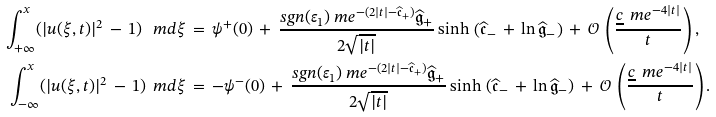Convert formula to latex. <formula><loc_0><loc_0><loc_500><loc_500>\int \nolimits _ { + \infty } ^ { x } ( | u ( \xi , t ) | ^ { 2 } \, - \, 1 ) \, \ m d \xi \, & = \, \psi ^ { + } ( 0 ) \, + \, \frac { s g n ( \varepsilon _ { 1 } ) \ m e ^ { - ( 2 | t | - \widehat { \mathfrak { c } } _ { + } ) } \widehat { \mathfrak { g } } _ { + } } { 2 \sqrt { | t | } } \sinh \, \left ( \widehat { \mathfrak { c } } _ { - } \, + \, \ln \widehat { \mathfrak { g } } _ { - } \right ) \, + \, \mathcal { O } \, \left ( \frac { \underline { c } \, \ m e ^ { - 4 | t | } } { t } \right ) , \\ \int \nolimits _ { - \infty } ^ { x } ( | u ( \xi , t ) | ^ { 2 } \, - \, 1 ) \, \ m d \xi \, & = \, - \psi ^ { - } ( 0 ) \, + \, \frac { s g n ( \varepsilon _ { 1 } ) \ m e ^ { - ( 2 | t | - \widehat { \mathfrak { c } } _ { + } ) } \widehat { \mathfrak { g } } _ { + } } { 2 \sqrt { | t | } } \sinh \, \left ( \widehat { \mathfrak { c } } _ { - } \, + \, \ln \widehat { \mathfrak { g } } _ { - } \right ) \, + \, \mathcal { O } \, \left ( \frac { \underline { c } \, \ m e ^ { - 4 | t | } } { t } \right ) .</formula> 